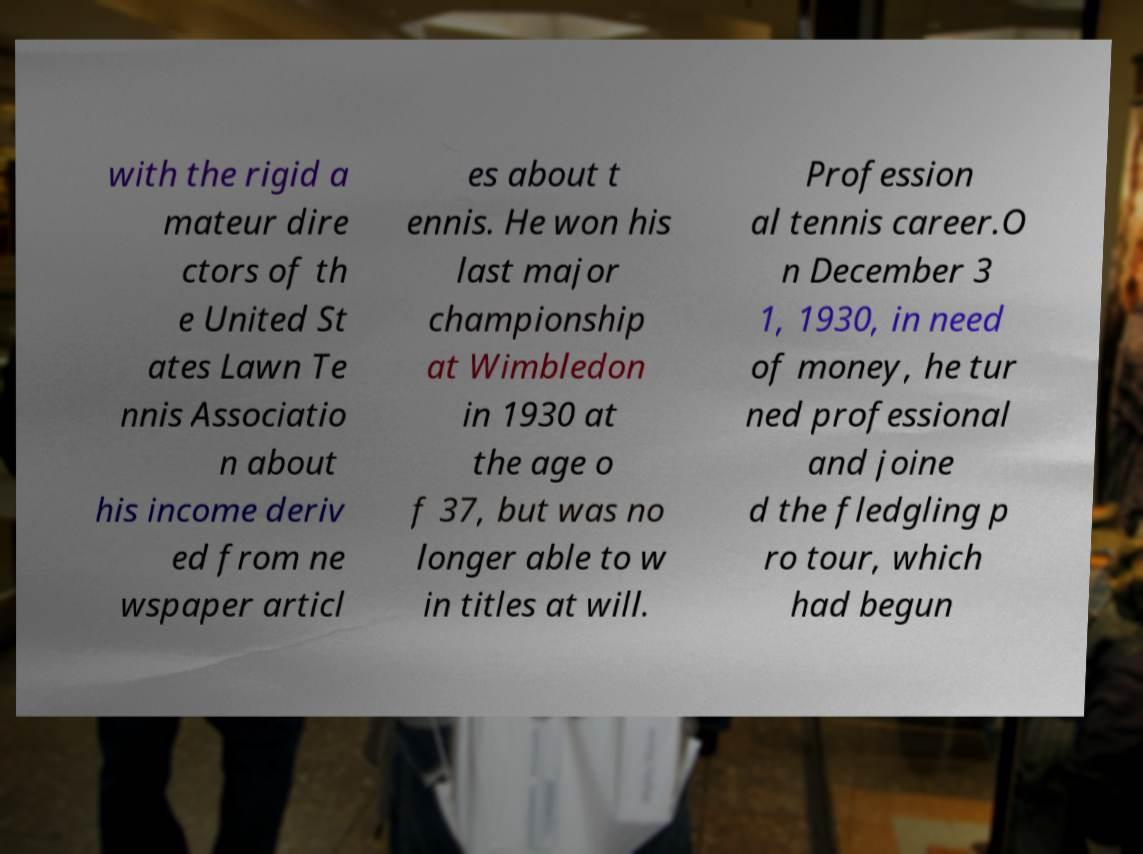I need the written content from this picture converted into text. Can you do that? with the rigid a mateur dire ctors of th e United St ates Lawn Te nnis Associatio n about his income deriv ed from ne wspaper articl es about t ennis. He won his last major championship at Wimbledon in 1930 at the age o f 37, but was no longer able to w in titles at will. Profession al tennis career.O n December 3 1, 1930, in need of money, he tur ned professional and joine d the fledgling p ro tour, which had begun 